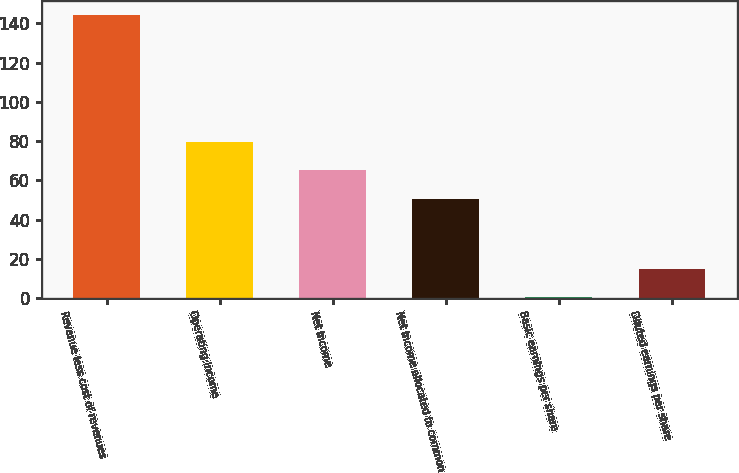Convert chart to OTSL. <chart><loc_0><loc_0><loc_500><loc_500><bar_chart><fcel>Revenue less cost of revenues<fcel>Operating income<fcel>Net income<fcel>Net income allocated to common<fcel>Basic earnings per share<fcel>Diluted earnings per share<nl><fcel>144.1<fcel>79.4<fcel>65.05<fcel>50.7<fcel>0.62<fcel>14.97<nl></chart> 